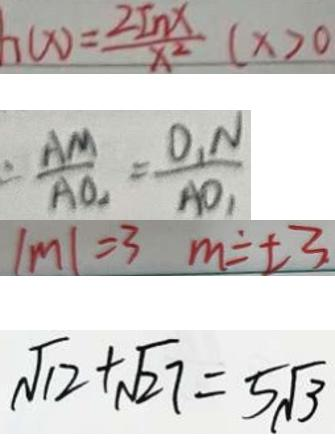<formula> <loc_0><loc_0><loc_500><loc_500>h ( x ) = \frac { 2 I n x } { x ^ { 2 } } ( x > 0 
 = \frac { A M } { A O _ { 2 } } = \frac { O _ { 1 } N } { A O _ { 1 } } 
 \vert m \vert = 3 m = \pm 3 
 \sqrt { 1 2 } + \sqrt { 2 7 } = 5 \sqrt { 3 }</formula> 